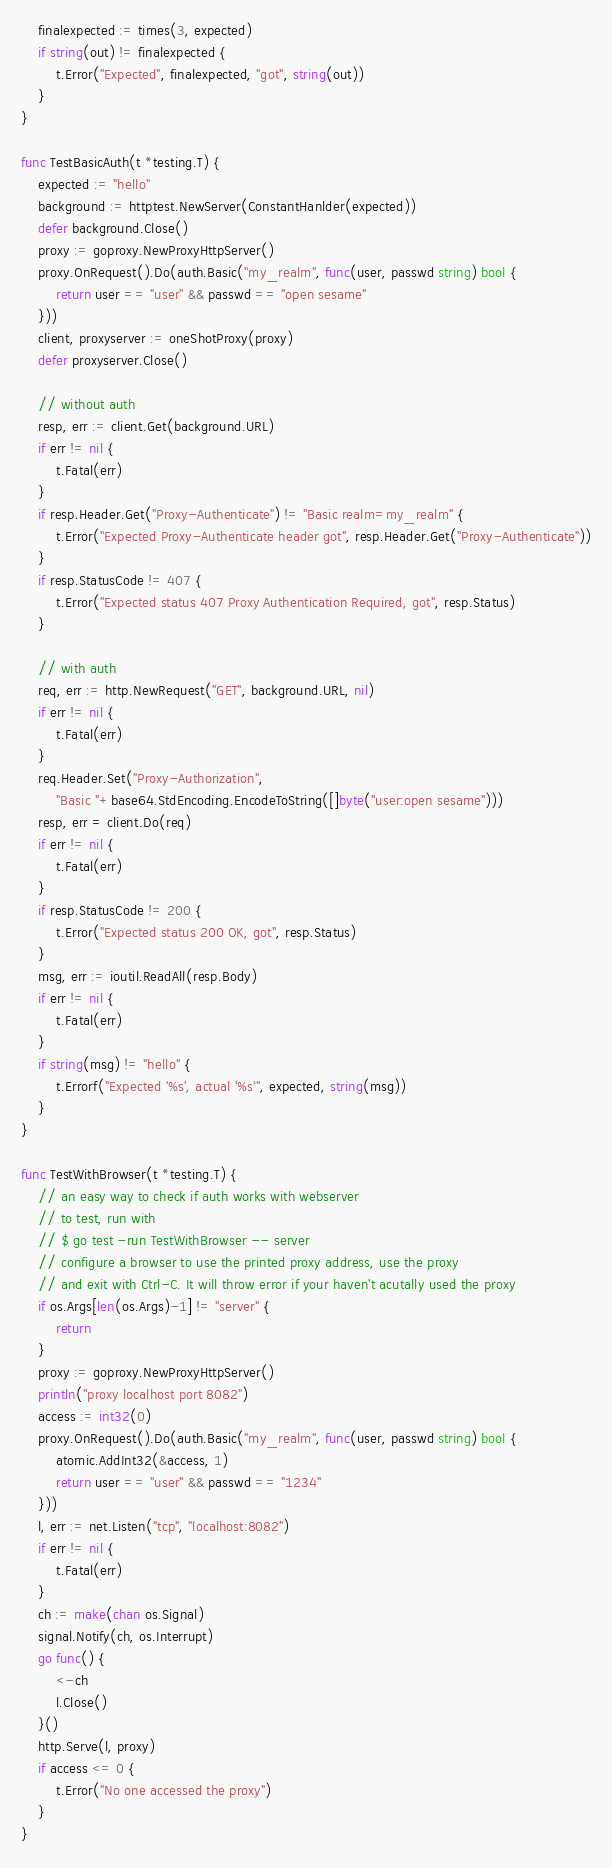<code> <loc_0><loc_0><loc_500><loc_500><_Go_>	finalexpected := times(3, expected)
	if string(out) != finalexpected {
		t.Error("Expected", finalexpected, "got", string(out))
	}
}

func TestBasicAuth(t *testing.T) {
	expected := "hello"
	background := httptest.NewServer(ConstantHanlder(expected))
	defer background.Close()
	proxy := goproxy.NewProxyHttpServer()
	proxy.OnRequest().Do(auth.Basic("my_realm", func(user, passwd string) bool {
		return user == "user" && passwd == "open sesame"
	}))
	client, proxyserver := oneShotProxy(proxy)
	defer proxyserver.Close()

	// without auth
	resp, err := client.Get(background.URL)
	if err != nil {
		t.Fatal(err)
	}
	if resp.Header.Get("Proxy-Authenticate") != "Basic realm=my_realm" {
		t.Error("Expected Proxy-Authenticate header got", resp.Header.Get("Proxy-Authenticate"))
	}
	if resp.StatusCode != 407 {
		t.Error("Expected status 407 Proxy Authentication Required, got", resp.Status)
	}

	// with auth
	req, err := http.NewRequest("GET", background.URL, nil)
	if err != nil {
		t.Fatal(err)
	}
	req.Header.Set("Proxy-Authorization",
		"Basic "+base64.StdEncoding.EncodeToString([]byte("user:open sesame")))
	resp, err = client.Do(req)
	if err != nil {
		t.Fatal(err)
	}
	if resp.StatusCode != 200 {
		t.Error("Expected status 200 OK, got", resp.Status)
	}
	msg, err := ioutil.ReadAll(resp.Body)
	if err != nil {
		t.Fatal(err)
	}
	if string(msg) != "hello" {
		t.Errorf("Expected '%s', actual '%s'", expected, string(msg))
	}
}

func TestWithBrowser(t *testing.T) {
	// an easy way to check if auth works with webserver
	// to test, run with
	// $ go test -run TestWithBrowser -- server
	// configure a browser to use the printed proxy address, use the proxy
	// and exit with Ctrl-C. It will throw error if your haven't acutally used the proxy
	if os.Args[len(os.Args)-1] != "server" {
		return
	}
	proxy := goproxy.NewProxyHttpServer()
	println("proxy localhost port 8082")
	access := int32(0)
	proxy.OnRequest().Do(auth.Basic("my_realm", func(user, passwd string) bool {
		atomic.AddInt32(&access, 1)
		return user == "user" && passwd == "1234"
	}))
	l, err := net.Listen("tcp", "localhost:8082")
	if err != nil {
		t.Fatal(err)
	}
	ch := make(chan os.Signal)
	signal.Notify(ch, os.Interrupt)
	go func() {
		<-ch
		l.Close()
	}()
	http.Serve(l, proxy)
	if access <= 0 {
		t.Error("No one accessed the proxy")
	}
}
</code> 